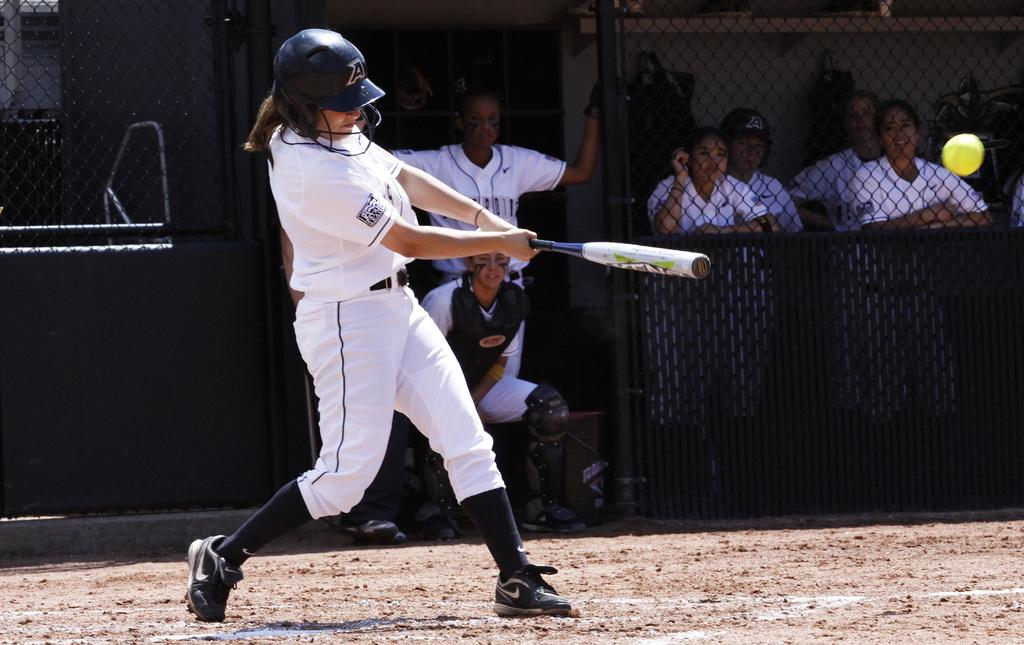<image>
Render a clear and concise summary of the photo. The girl hitting the ball has the letter A on he helmet. 